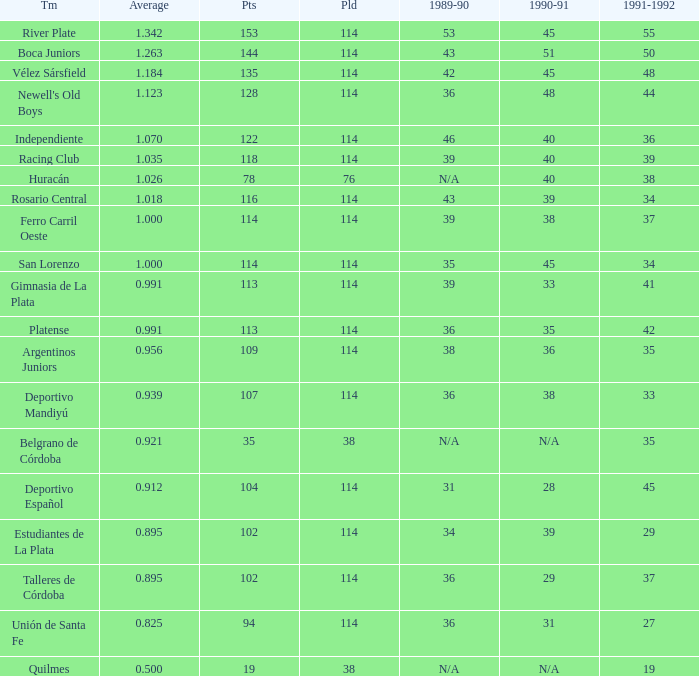Give me the full table as a dictionary. {'header': ['Tm', 'Average', 'Pts', 'Pld', '1989-90', '1990-91', '1991-1992'], 'rows': [['River Plate', '1.342', '153', '114', '53', '45', '55'], ['Boca Juniors', '1.263', '144', '114', '43', '51', '50'], ['Vélez Sársfield', '1.184', '135', '114', '42', '45', '48'], ["Newell's Old Boys", '1.123', '128', '114', '36', '48', '44'], ['Independiente', '1.070', '122', '114', '46', '40', '36'], ['Racing Club', '1.035', '118', '114', '39', '40', '39'], ['Huracán', '1.026', '78', '76', 'N/A', '40', '38'], ['Rosario Central', '1.018', '116', '114', '43', '39', '34'], ['Ferro Carril Oeste', '1.000', '114', '114', '39', '38', '37'], ['San Lorenzo', '1.000', '114', '114', '35', '45', '34'], ['Gimnasia de La Plata', '0.991', '113', '114', '39', '33', '41'], ['Platense', '0.991', '113', '114', '36', '35', '42'], ['Argentinos Juniors', '0.956', '109', '114', '38', '36', '35'], ['Deportivo Mandiyú', '0.939', '107', '114', '36', '38', '33'], ['Belgrano de Córdoba', '0.921', '35', '38', 'N/A', 'N/A', '35'], ['Deportivo Español', '0.912', '104', '114', '31', '28', '45'], ['Estudiantes de La Plata', '0.895', '102', '114', '34', '39', '29'], ['Talleres de Córdoba', '0.895', '102', '114', '36', '29', '37'], ['Unión de Santa Fe', '0.825', '94', '114', '36', '31', '27'], ['Quilmes', '0.500', '19', '38', 'N/A', 'N/A', '19']]} How much 1991-1992 has a 1989-90 of 36, and an Average of 0.8250000000000001? 0.0. 